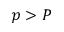Convert formula to latex. <formula><loc_0><loc_0><loc_500><loc_500>p > P</formula> 